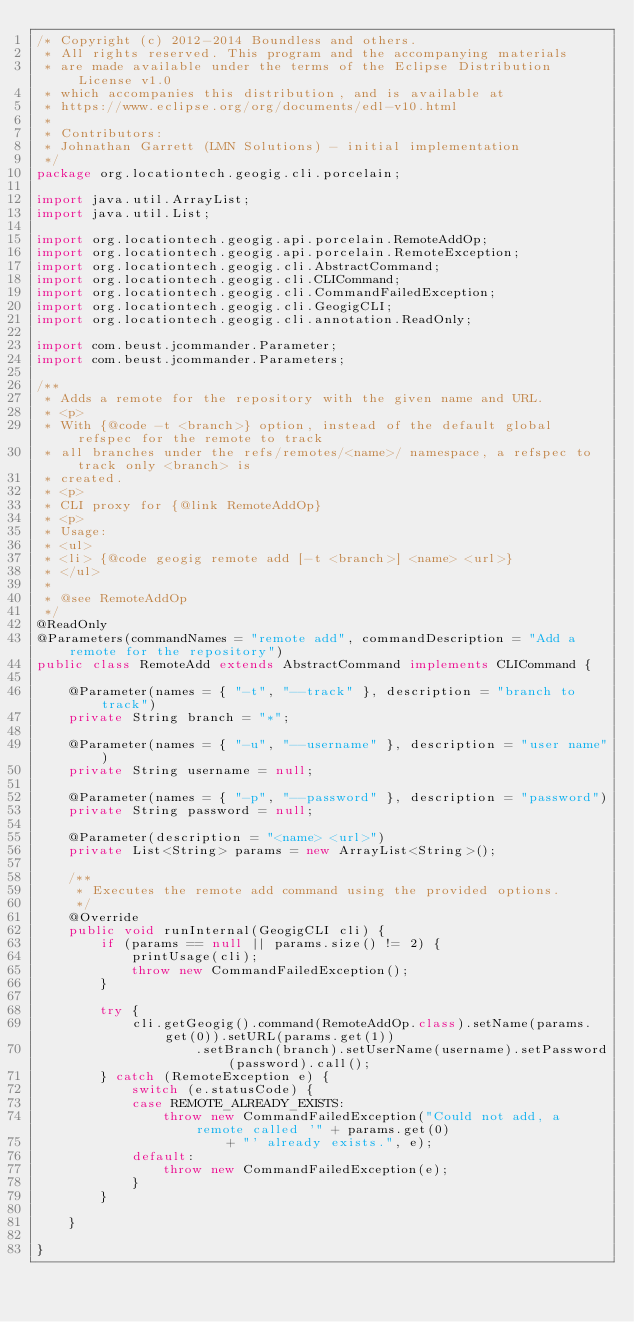<code> <loc_0><loc_0><loc_500><loc_500><_Java_>/* Copyright (c) 2012-2014 Boundless and others.
 * All rights reserved. This program and the accompanying materials
 * are made available under the terms of the Eclipse Distribution License v1.0
 * which accompanies this distribution, and is available at
 * https://www.eclipse.org/org/documents/edl-v10.html
 *
 * Contributors:
 * Johnathan Garrett (LMN Solutions) - initial implementation
 */
package org.locationtech.geogig.cli.porcelain;

import java.util.ArrayList;
import java.util.List;

import org.locationtech.geogig.api.porcelain.RemoteAddOp;
import org.locationtech.geogig.api.porcelain.RemoteException;
import org.locationtech.geogig.cli.AbstractCommand;
import org.locationtech.geogig.cli.CLICommand;
import org.locationtech.geogig.cli.CommandFailedException;
import org.locationtech.geogig.cli.GeogigCLI;
import org.locationtech.geogig.cli.annotation.ReadOnly;

import com.beust.jcommander.Parameter;
import com.beust.jcommander.Parameters;

/**
 * Adds a remote for the repository with the given name and URL.
 * <p>
 * With {@code -t <branch>} option, instead of the default global refspec for the remote to track
 * all branches under the refs/remotes/<name>/ namespace, a refspec to track only <branch> is
 * created.
 * <p>
 * CLI proxy for {@link RemoteAddOp}
 * <p>
 * Usage:
 * <ul>
 * <li> {@code geogig remote add [-t <branch>] <name> <url>}
 * </ul>
 * 
 * @see RemoteAddOp
 */
@ReadOnly
@Parameters(commandNames = "remote add", commandDescription = "Add a remote for the repository")
public class RemoteAdd extends AbstractCommand implements CLICommand {

    @Parameter(names = { "-t", "--track" }, description = "branch to track")
    private String branch = "*";

    @Parameter(names = { "-u", "--username" }, description = "user name")
    private String username = null;

    @Parameter(names = { "-p", "--password" }, description = "password")
    private String password = null;

    @Parameter(description = "<name> <url>")
    private List<String> params = new ArrayList<String>();

    /**
     * Executes the remote add command using the provided options.
     */
    @Override
    public void runInternal(GeogigCLI cli) {
        if (params == null || params.size() != 2) {
            printUsage(cli);
            throw new CommandFailedException();
        }

        try {
            cli.getGeogig().command(RemoteAddOp.class).setName(params.get(0)).setURL(params.get(1))
                    .setBranch(branch).setUserName(username).setPassword(password).call();
        } catch (RemoteException e) {
            switch (e.statusCode) {
            case REMOTE_ALREADY_EXISTS:
                throw new CommandFailedException("Could not add, a remote called '" + params.get(0)
                        + "' already exists.", e);
            default:
                throw new CommandFailedException(e);
            }
        }

    }

}
</code> 